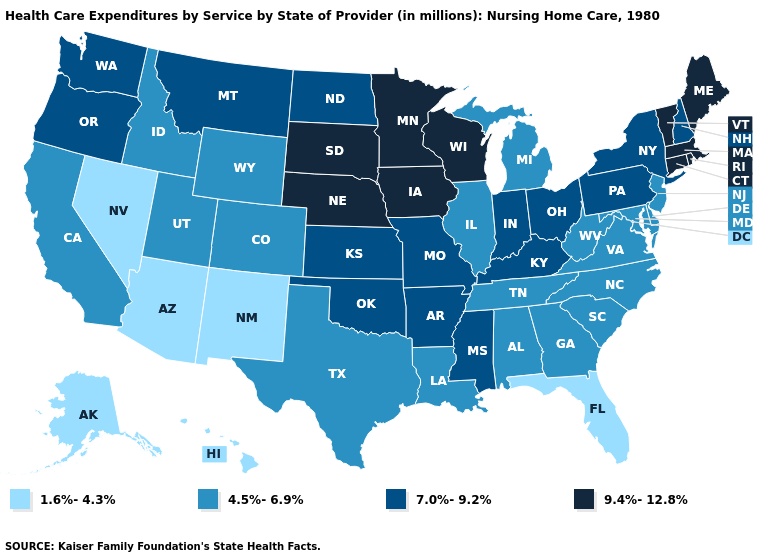Name the states that have a value in the range 1.6%-4.3%?
Quick response, please. Alaska, Arizona, Florida, Hawaii, Nevada, New Mexico. Among the states that border Virginia , does Kentucky have the highest value?
Be succinct. Yes. Name the states that have a value in the range 7.0%-9.2%?
Quick response, please. Arkansas, Indiana, Kansas, Kentucky, Mississippi, Missouri, Montana, New Hampshire, New York, North Dakota, Ohio, Oklahoma, Oregon, Pennsylvania, Washington. Among the states that border Idaho , which have the highest value?
Concise answer only. Montana, Oregon, Washington. Name the states that have a value in the range 4.5%-6.9%?
Quick response, please. Alabama, California, Colorado, Delaware, Georgia, Idaho, Illinois, Louisiana, Maryland, Michigan, New Jersey, North Carolina, South Carolina, Tennessee, Texas, Utah, Virginia, West Virginia, Wyoming. What is the lowest value in the MidWest?
Quick response, please. 4.5%-6.9%. Does the first symbol in the legend represent the smallest category?
Quick response, please. Yes. What is the highest value in the USA?
Give a very brief answer. 9.4%-12.8%. Name the states that have a value in the range 1.6%-4.3%?
Keep it brief. Alaska, Arizona, Florida, Hawaii, Nevada, New Mexico. What is the value of Indiana?
Keep it brief. 7.0%-9.2%. Which states hav the highest value in the MidWest?
Short answer required. Iowa, Minnesota, Nebraska, South Dakota, Wisconsin. What is the value of West Virginia?
Quick response, please. 4.5%-6.9%. Name the states that have a value in the range 1.6%-4.3%?
Give a very brief answer. Alaska, Arizona, Florida, Hawaii, Nevada, New Mexico. Does the first symbol in the legend represent the smallest category?
Be succinct. Yes. Name the states that have a value in the range 4.5%-6.9%?
Give a very brief answer. Alabama, California, Colorado, Delaware, Georgia, Idaho, Illinois, Louisiana, Maryland, Michigan, New Jersey, North Carolina, South Carolina, Tennessee, Texas, Utah, Virginia, West Virginia, Wyoming. 